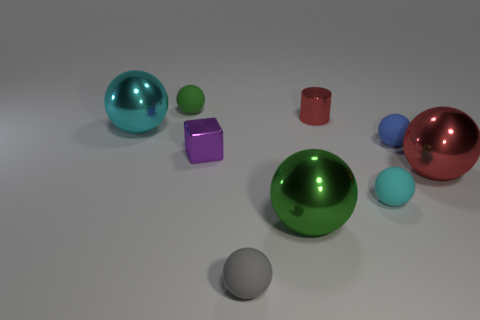Add 1 big blue shiny cylinders. How many objects exist? 10 Subtract all green spheres. How many spheres are left? 5 Subtract all gray matte spheres. How many spheres are left? 6 Subtract 0 brown blocks. How many objects are left? 9 Subtract all cylinders. How many objects are left? 8 Subtract 1 cylinders. How many cylinders are left? 0 Subtract all red balls. Subtract all purple blocks. How many balls are left? 6 Subtract all blue cubes. How many gray cylinders are left? 0 Subtract all small green things. Subtract all tiny gray matte balls. How many objects are left? 7 Add 3 small gray spheres. How many small gray spheres are left? 4 